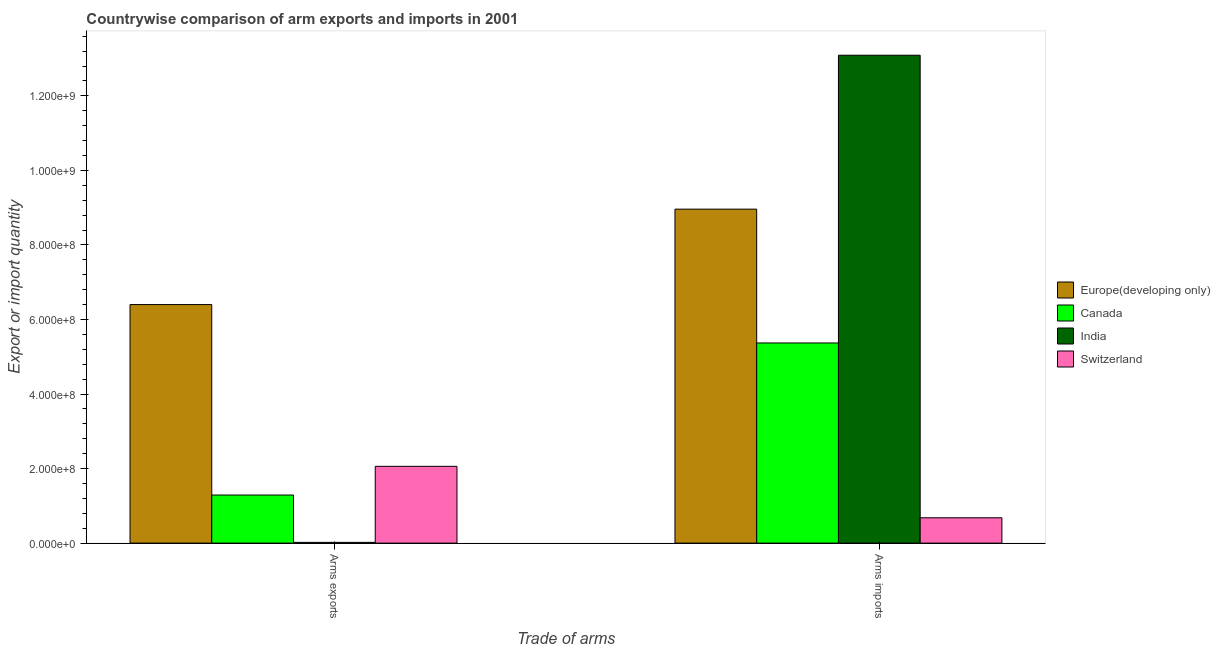How many different coloured bars are there?
Your response must be concise. 4. Are the number of bars per tick equal to the number of legend labels?
Ensure brevity in your answer.  Yes. How many bars are there on the 1st tick from the left?
Make the answer very short. 4. What is the label of the 2nd group of bars from the left?
Offer a terse response. Arms imports. What is the arms exports in India?
Your response must be concise. 2.00e+06. Across all countries, what is the maximum arms imports?
Offer a terse response. 1.31e+09. Across all countries, what is the minimum arms exports?
Provide a succinct answer. 2.00e+06. In which country was the arms imports minimum?
Make the answer very short. Switzerland. What is the total arms exports in the graph?
Keep it short and to the point. 9.77e+08. What is the difference between the arms imports in India and that in Canada?
Your answer should be very brief. 7.72e+08. What is the difference between the arms exports in India and the arms imports in Europe(developing only)?
Offer a very short reply. -8.94e+08. What is the average arms imports per country?
Ensure brevity in your answer.  7.02e+08. What is the difference between the arms imports and arms exports in Europe(developing only)?
Provide a succinct answer. 2.56e+08. In how many countries, is the arms exports greater than 400000000 ?
Keep it short and to the point. 1. What is the ratio of the arms imports in Switzerland to that in India?
Your answer should be compact. 0.05. Is the arms imports in India less than that in Europe(developing only)?
Ensure brevity in your answer.  No. In how many countries, is the arms imports greater than the average arms imports taken over all countries?
Make the answer very short. 2. What does the 4th bar from the left in Arms imports represents?
Offer a terse response. Switzerland. Are the values on the major ticks of Y-axis written in scientific E-notation?
Give a very brief answer. Yes. How many legend labels are there?
Offer a terse response. 4. How are the legend labels stacked?
Offer a very short reply. Vertical. What is the title of the graph?
Your answer should be compact. Countrywise comparison of arm exports and imports in 2001. Does "Northern Mariana Islands" appear as one of the legend labels in the graph?
Offer a terse response. No. What is the label or title of the X-axis?
Offer a terse response. Trade of arms. What is the label or title of the Y-axis?
Provide a short and direct response. Export or import quantity. What is the Export or import quantity in Europe(developing only) in Arms exports?
Offer a very short reply. 6.40e+08. What is the Export or import quantity of Canada in Arms exports?
Make the answer very short. 1.29e+08. What is the Export or import quantity in India in Arms exports?
Provide a short and direct response. 2.00e+06. What is the Export or import quantity of Switzerland in Arms exports?
Give a very brief answer. 2.06e+08. What is the Export or import quantity of Europe(developing only) in Arms imports?
Your answer should be very brief. 8.96e+08. What is the Export or import quantity of Canada in Arms imports?
Make the answer very short. 5.37e+08. What is the Export or import quantity of India in Arms imports?
Your answer should be very brief. 1.31e+09. What is the Export or import quantity in Switzerland in Arms imports?
Offer a terse response. 6.80e+07. Across all Trade of arms, what is the maximum Export or import quantity of Europe(developing only)?
Your answer should be very brief. 8.96e+08. Across all Trade of arms, what is the maximum Export or import quantity in Canada?
Your response must be concise. 5.37e+08. Across all Trade of arms, what is the maximum Export or import quantity in India?
Provide a short and direct response. 1.31e+09. Across all Trade of arms, what is the maximum Export or import quantity of Switzerland?
Your answer should be very brief. 2.06e+08. Across all Trade of arms, what is the minimum Export or import quantity of Europe(developing only)?
Your response must be concise. 6.40e+08. Across all Trade of arms, what is the minimum Export or import quantity in Canada?
Provide a succinct answer. 1.29e+08. Across all Trade of arms, what is the minimum Export or import quantity in Switzerland?
Your response must be concise. 6.80e+07. What is the total Export or import quantity in Europe(developing only) in the graph?
Ensure brevity in your answer.  1.54e+09. What is the total Export or import quantity in Canada in the graph?
Keep it short and to the point. 6.66e+08. What is the total Export or import quantity in India in the graph?
Your response must be concise. 1.31e+09. What is the total Export or import quantity of Switzerland in the graph?
Provide a short and direct response. 2.74e+08. What is the difference between the Export or import quantity of Europe(developing only) in Arms exports and that in Arms imports?
Make the answer very short. -2.56e+08. What is the difference between the Export or import quantity of Canada in Arms exports and that in Arms imports?
Offer a very short reply. -4.08e+08. What is the difference between the Export or import quantity of India in Arms exports and that in Arms imports?
Provide a short and direct response. -1.31e+09. What is the difference between the Export or import quantity in Switzerland in Arms exports and that in Arms imports?
Provide a short and direct response. 1.38e+08. What is the difference between the Export or import quantity of Europe(developing only) in Arms exports and the Export or import quantity of Canada in Arms imports?
Give a very brief answer. 1.03e+08. What is the difference between the Export or import quantity of Europe(developing only) in Arms exports and the Export or import quantity of India in Arms imports?
Provide a succinct answer. -6.69e+08. What is the difference between the Export or import quantity of Europe(developing only) in Arms exports and the Export or import quantity of Switzerland in Arms imports?
Your answer should be compact. 5.72e+08. What is the difference between the Export or import quantity in Canada in Arms exports and the Export or import quantity in India in Arms imports?
Your answer should be compact. -1.18e+09. What is the difference between the Export or import quantity of Canada in Arms exports and the Export or import quantity of Switzerland in Arms imports?
Give a very brief answer. 6.10e+07. What is the difference between the Export or import quantity in India in Arms exports and the Export or import quantity in Switzerland in Arms imports?
Your answer should be compact. -6.60e+07. What is the average Export or import quantity in Europe(developing only) per Trade of arms?
Ensure brevity in your answer.  7.68e+08. What is the average Export or import quantity of Canada per Trade of arms?
Your response must be concise. 3.33e+08. What is the average Export or import quantity in India per Trade of arms?
Ensure brevity in your answer.  6.56e+08. What is the average Export or import quantity of Switzerland per Trade of arms?
Your answer should be compact. 1.37e+08. What is the difference between the Export or import quantity of Europe(developing only) and Export or import quantity of Canada in Arms exports?
Provide a short and direct response. 5.11e+08. What is the difference between the Export or import quantity in Europe(developing only) and Export or import quantity in India in Arms exports?
Ensure brevity in your answer.  6.38e+08. What is the difference between the Export or import quantity in Europe(developing only) and Export or import quantity in Switzerland in Arms exports?
Provide a short and direct response. 4.34e+08. What is the difference between the Export or import quantity in Canada and Export or import quantity in India in Arms exports?
Provide a short and direct response. 1.27e+08. What is the difference between the Export or import quantity in Canada and Export or import quantity in Switzerland in Arms exports?
Provide a succinct answer. -7.70e+07. What is the difference between the Export or import quantity in India and Export or import quantity in Switzerland in Arms exports?
Your answer should be compact. -2.04e+08. What is the difference between the Export or import quantity in Europe(developing only) and Export or import quantity in Canada in Arms imports?
Provide a succinct answer. 3.59e+08. What is the difference between the Export or import quantity in Europe(developing only) and Export or import quantity in India in Arms imports?
Your answer should be very brief. -4.13e+08. What is the difference between the Export or import quantity in Europe(developing only) and Export or import quantity in Switzerland in Arms imports?
Your answer should be very brief. 8.28e+08. What is the difference between the Export or import quantity in Canada and Export or import quantity in India in Arms imports?
Ensure brevity in your answer.  -7.72e+08. What is the difference between the Export or import quantity in Canada and Export or import quantity in Switzerland in Arms imports?
Keep it short and to the point. 4.69e+08. What is the difference between the Export or import quantity of India and Export or import quantity of Switzerland in Arms imports?
Your answer should be compact. 1.24e+09. What is the ratio of the Export or import quantity of Europe(developing only) in Arms exports to that in Arms imports?
Your answer should be very brief. 0.71. What is the ratio of the Export or import quantity in Canada in Arms exports to that in Arms imports?
Offer a very short reply. 0.24. What is the ratio of the Export or import quantity in India in Arms exports to that in Arms imports?
Ensure brevity in your answer.  0. What is the ratio of the Export or import quantity in Switzerland in Arms exports to that in Arms imports?
Your response must be concise. 3.03. What is the difference between the highest and the second highest Export or import quantity of Europe(developing only)?
Make the answer very short. 2.56e+08. What is the difference between the highest and the second highest Export or import quantity of Canada?
Your answer should be very brief. 4.08e+08. What is the difference between the highest and the second highest Export or import quantity in India?
Offer a terse response. 1.31e+09. What is the difference between the highest and the second highest Export or import quantity of Switzerland?
Ensure brevity in your answer.  1.38e+08. What is the difference between the highest and the lowest Export or import quantity in Europe(developing only)?
Give a very brief answer. 2.56e+08. What is the difference between the highest and the lowest Export or import quantity in Canada?
Your response must be concise. 4.08e+08. What is the difference between the highest and the lowest Export or import quantity in India?
Your answer should be very brief. 1.31e+09. What is the difference between the highest and the lowest Export or import quantity in Switzerland?
Provide a short and direct response. 1.38e+08. 